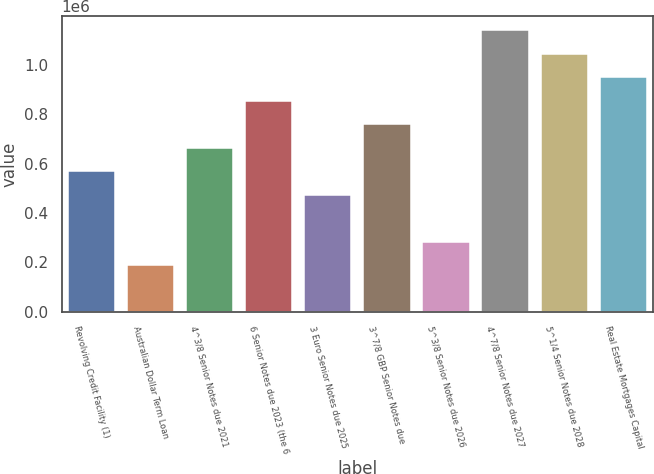Convert chart. <chart><loc_0><loc_0><loc_500><loc_500><bar_chart><fcel>Revolving Credit Facility (1)<fcel>Australian Dollar Term Loan<fcel>4^3/8 Senior Notes due 2021<fcel>6 Senior Notes due 2023 (the 6<fcel>3 Euro Senior Notes due 2025<fcel>3^7/8 GBP Senior Notes due<fcel>5^3/8 Senior Notes due 2026<fcel>4^7/8 Senior Notes due 2027<fcel>5^1/4 Senior Notes due 2028<fcel>Real Estate Mortgages Capital<nl><fcel>569049<fcel>189049<fcel>664049<fcel>854049<fcel>474049<fcel>759049<fcel>284049<fcel>1.13905e+06<fcel>1.04405e+06<fcel>949049<nl></chart> 